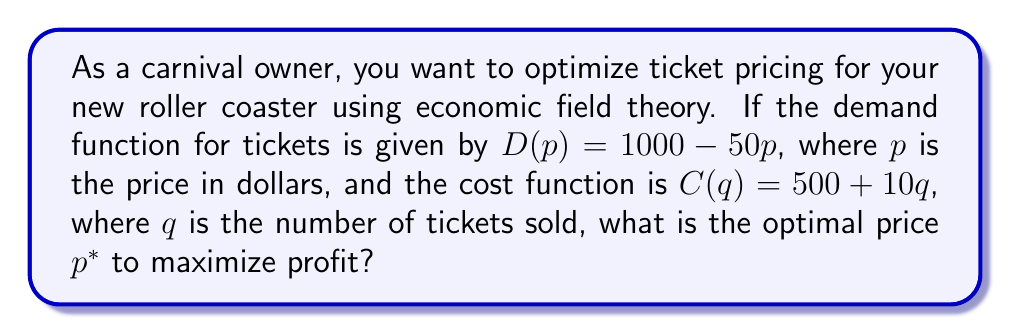Show me your answer to this math problem. Let's approach this step-by-step using economic field theory:

1) The profit function $\Pi(p)$ is given by revenue minus cost:
   $$\Pi(p) = pD(p) - C(D(p))$$

2) Substitute the given functions:
   $$\Pi(p) = p(1000 - 50p) - [500 + 10(1000 - 50p)]$$

3) Expand the equation:
   $$\Pi(p) = 1000p - 50p^2 - 500 - 10000 + 500p$$
   $$\Pi(p) = -50p^2 + 1500p - 10500$$

4) To find the maximum profit, we need to find the critical point. Take the derivative and set it to zero:
   $$\frac{d\Pi}{dp} = -100p + 1500 = 0$$

5) Solve for $p$:
   $$-100p = -1500$$
   $$p = 15$$

6) To confirm this is a maximum, check the second derivative:
   $$\frac{d^2\Pi}{dp^2} = -100 < 0$$
   This confirms that $p = 15$ is indeed a maximum.

Therefore, the optimal price $p^*$ is $15.
Answer: $15 